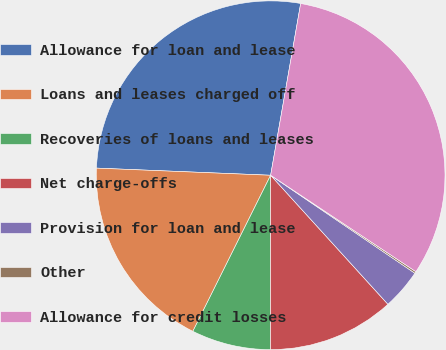Convert chart to OTSL. <chart><loc_0><loc_0><loc_500><loc_500><pie_chart><fcel>Allowance for loan and lease<fcel>Loans and leases charged off<fcel>Recoveries of loans and leases<fcel>Net charge-offs<fcel>Provision for loan and lease<fcel>Other<fcel>Allowance for credit losses<nl><fcel>27.1%<fcel>18.29%<fcel>7.35%<fcel>11.75%<fcel>3.76%<fcel>0.17%<fcel>31.57%<nl></chart> 